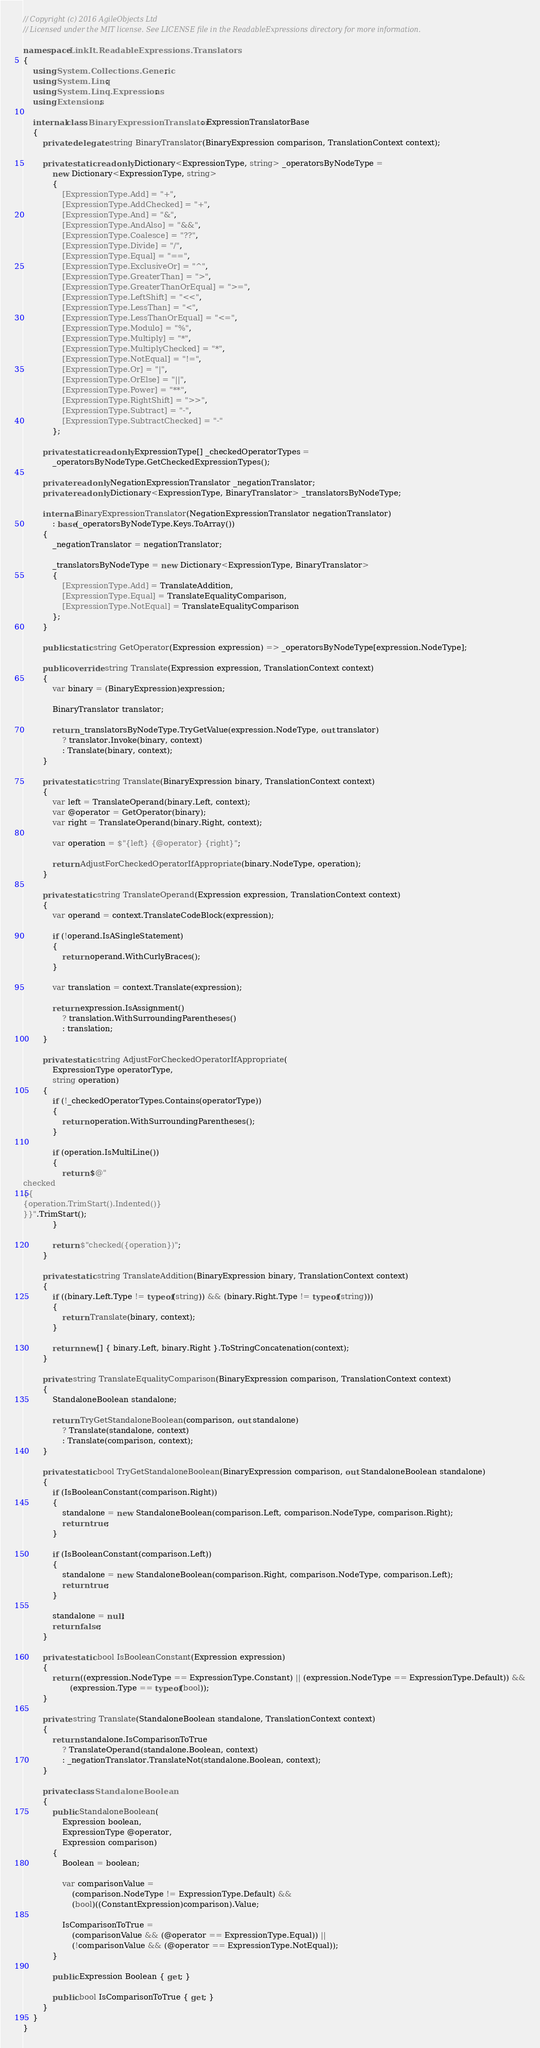<code> <loc_0><loc_0><loc_500><loc_500><_C#_>// Copyright (c) 2016 AgileObjects Ltd
// Licensed under the MIT license. See LICENSE file in the ReadableExpressions directory for more information.

namespace LinkIt.ReadableExpressions.Translators
{
    using System.Collections.Generic;
    using System.Linq;
    using System.Linq.Expressions;
    using Extensions;

    internal class BinaryExpressionTranslator : ExpressionTranslatorBase
    {
        private delegate string BinaryTranslator(BinaryExpression comparison, TranslationContext context);

        private static readonly Dictionary<ExpressionType, string> _operatorsByNodeType =
            new Dictionary<ExpressionType, string>
            {
                [ExpressionType.Add] = "+",
                [ExpressionType.AddChecked] = "+",
                [ExpressionType.And] = "&",
                [ExpressionType.AndAlso] = "&&",
                [ExpressionType.Coalesce] = "??",
                [ExpressionType.Divide] = "/",
                [ExpressionType.Equal] = "==",
                [ExpressionType.ExclusiveOr] = "^",
                [ExpressionType.GreaterThan] = ">",
                [ExpressionType.GreaterThanOrEqual] = ">=",
                [ExpressionType.LeftShift] = "<<",
                [ExpressionType.LessThan] = "<",
                [ExpressionType.LessThanOrEqual] = "<=",
                [ExpressionType.Modulo] = "%",
                [ExpressionType.Multiply] = "*",
                [ExpressionType.MultiplyChecked] = "*",
                [ExpressionType.NotEqual] = "!=",
                [ExpressionType.Or] = "|",
                [ExpressionType.OrElse] = "||",
                [ExpressionType.Power] = "**",
                [ExpressionType.RightShift] = ">>",
                [ExpressionType.Subtract] = "-",
                [ExpressionType.SubtractChecked] = "-"
            };

        private static readonly ExpressionType[] _checkedOperatorTypes =
            _operatorsByNodeType.GetCheckedExpressionTypes();

        private readonly NegationExpressionTranslator _negationTranslator;
        private readonly Dictionary<ExpressionType, BinaryTranslator> _translatorsByNodeType;

        internal BinaryExpressionTranslator(NegationExpressionTranslator negationTranslator)
            : base(_operatorsByNodeType.Keys.ToArray())
        {
            _negationTranslator = negationTranslator;

            _translatorsByNodeType = new Dictionary<ExpressionType, BinaryTranslator>
            {
                [ExpressionType.Add] = TranslateAddition,
                [ExpressionType.Equal] = TranslateEqualityComparison,
                [ExpressionType.NotEqual] = TranslateEqualityComparison
            };
        }

        public static string GetOperator(Expression expression) => _operatorsByNodeType[expression.NodeType];

        public override string Translate(Expression expression, TranslationContext context)
        {
            var binary = (BinaryExpression)expression;

            BinaryTranslator translator;

            return _translatorsByNodeType.TryGetValue(expression.NodeType, out translator)
                ? translator.Invoke(binary, context)
                : Translate(binary, context);
        }

        private static string Translate(BinaryExpression binary, TranslationContext context)
        {
            var left = TranslateOperand(binary.Left, context);
            var @operator = GetOperator(binary);
            var right = TranslateOperand(binary.Right, context);

            var operation = $"{left} {@operator} {right}";

            return AdjustForCheckedOperatorIfAppropriate(binary.NodeType, operation);
        }

        private static string TranslateOperand(Expression expression, TranslationContext context)
        {
            var operand = context.TranslateCodeBlock(expression);

            if (!operand.IsASingleStatement)
            {
                return operand.WithCurlyBraces();
            }

            var translation = context.Translate(expression);

            return expression.IsAssignment()
                ? translation.WithSurroundingParentheses()
                : translation;
        }

        private static string AdjustForCheckedOperatorIfAppropriate(
            ExpressionType operatorType,
            string operation)
        {
            if (!_checkedOperatorTypes.Contains(operatorType))
            {
                return operation.WithSurroundingParentheses();
            }

            if (operation.IsMultiLine())
            {
                return $@"
checked
{{
{operation.TrimStart().Indented()}
}}".TrimStart();
            }

            return $"checked({operation})";
        }

        private static string TranslateAddition(BinaryExpression binary, TranslationContext context)
        {
            if ((binary.Left.Type != typeof(string)) && (binary.Right.Type != typeof(string)))
            {
                return Translate(binary, context);
            }

            return new[] { binary.Left, binary.Right }.ToStringConcatenation(context);
        }

        private string TranslateEqualityComparison(BinaryExpression comparison, TranslationContext context)
        {
            StandaloneBoolean standalone;

            return TryGetStandaloneBoolean(comparison, out standalone)
                ? Translate(standalone, context)
                : Translate(comparison, context);
        }

        private static bool TryGetStandaloneBoolean(BinaryExpression comparison, out StandaloneBoolean standalone)
        {
            if (IsBooleanConstant(comparison.Right))
            {
                standalone = new StandaloneBoolean(comparison.Left, comparison.NodeType, comparison.Right);
                return true;
            }

            if (IsBooleanConstant(comparison.Left))
            {
                standalone = new StandaloneBoolean(comparison.Right, comparison.NodeType, comparison.Left);
                return true;
            }

            standalone = null;
            return false;
        }

        private static bool IsBooleanConstant(Expression expression)
        {
            return ((expression.NodeType == ExpressionType.Constant) || (expression.NodeType == ExpressionType.Default)) &&
                   (expression.Type == typeof(bool));
        }

        private string Translate(StandaloneBoolean standalone, TranslationContext context)
        {
            return standalone.IsComparisonToTrue
                ? TranslateOperand(standalone.Boolean, context)
                : _negationTranslator.TranslateNot(standalone.Boolean, context);
        }

        private class StandaloneBoolean
        {
            public StandaloneBoolean(
                Expression boolean,
                ExpressionType @operator,
                Expression comparison)
            {
                Boolean = boolean;

                var comparisonValue =
                    (comparison.NodeType != ExpressionType.Default) &&
                    (bool)((ConstantExpression)comparison).Value;

                IsComparisonToTrue =
                    (comparisonValue && (@operator == ExpressionType.Equal)) ||
                    (!comparisonValue && (@operator == ExpressionType.NotEqual));
            }

            public Expression Boolean { get; }

            public bool IsComparisonToTrue { get; }
        }
    }
}</code> 